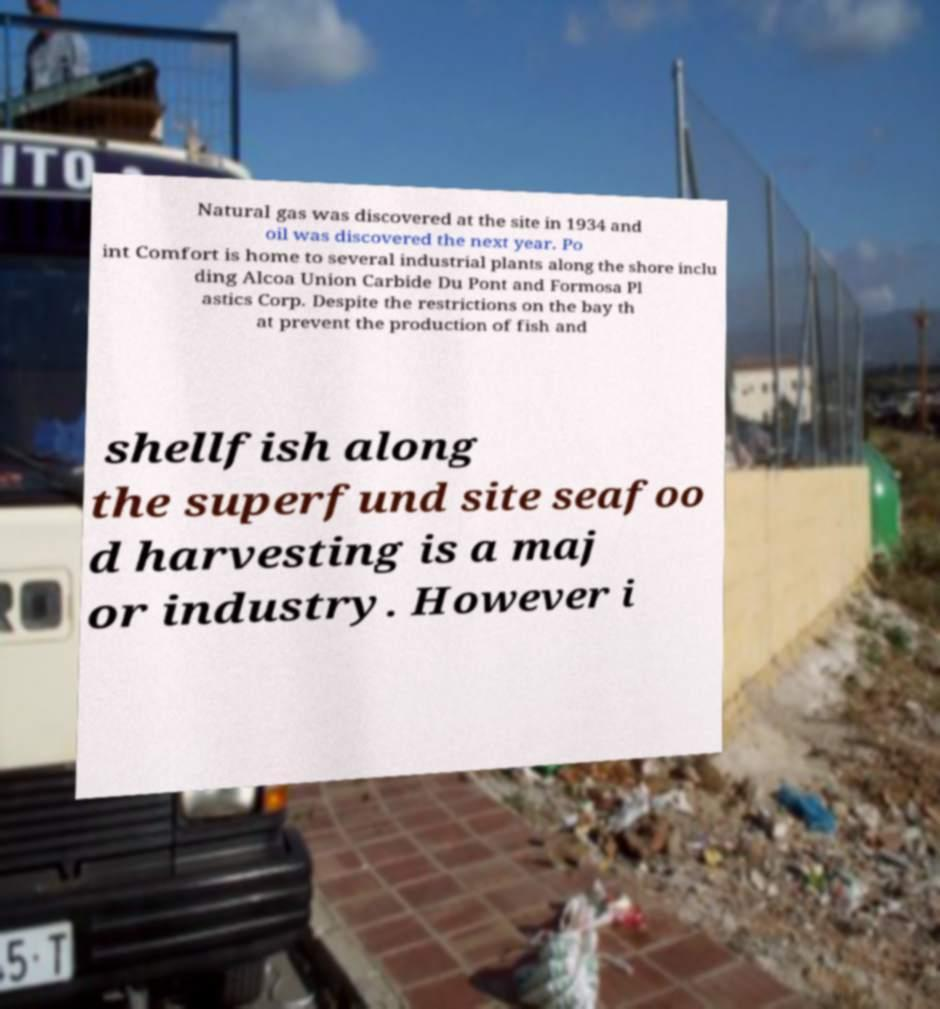Can you accurately transcribe the text from the provided image for me? Natural gas was discovered at the site in 1934 and oil was discovered the next year. Po int Comfort is home to several industrial plants along the shore inclu ding Alcoa Union Carbide Du Pont and Formosa Pl astics Corp. Despite the restrictions on the bay th at prevent the production of fish and shellfish along the superfund site seafoo d harvesting is a maj or industry. However i 